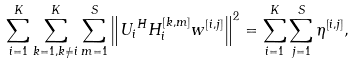<formula> <loc_0><loc_0><loc_500><loc_500>& \sum _ { i = 1 } ^ { K } \sum _ { k = 1 , k \neq i } ^ { K } \sum _ { m = 1 } ^ { S } \left \| { U _ { i } } ^ { H } H _ { i } ^ { [ k , m ] } w ^ { [ i , j ] } \right \| ^ { 2 } = \sum _ { i = 1 } ^ { K } \sum _ { j = 1 } ^ { S } \eta ^ { [ i , j ] } ,</formula> 